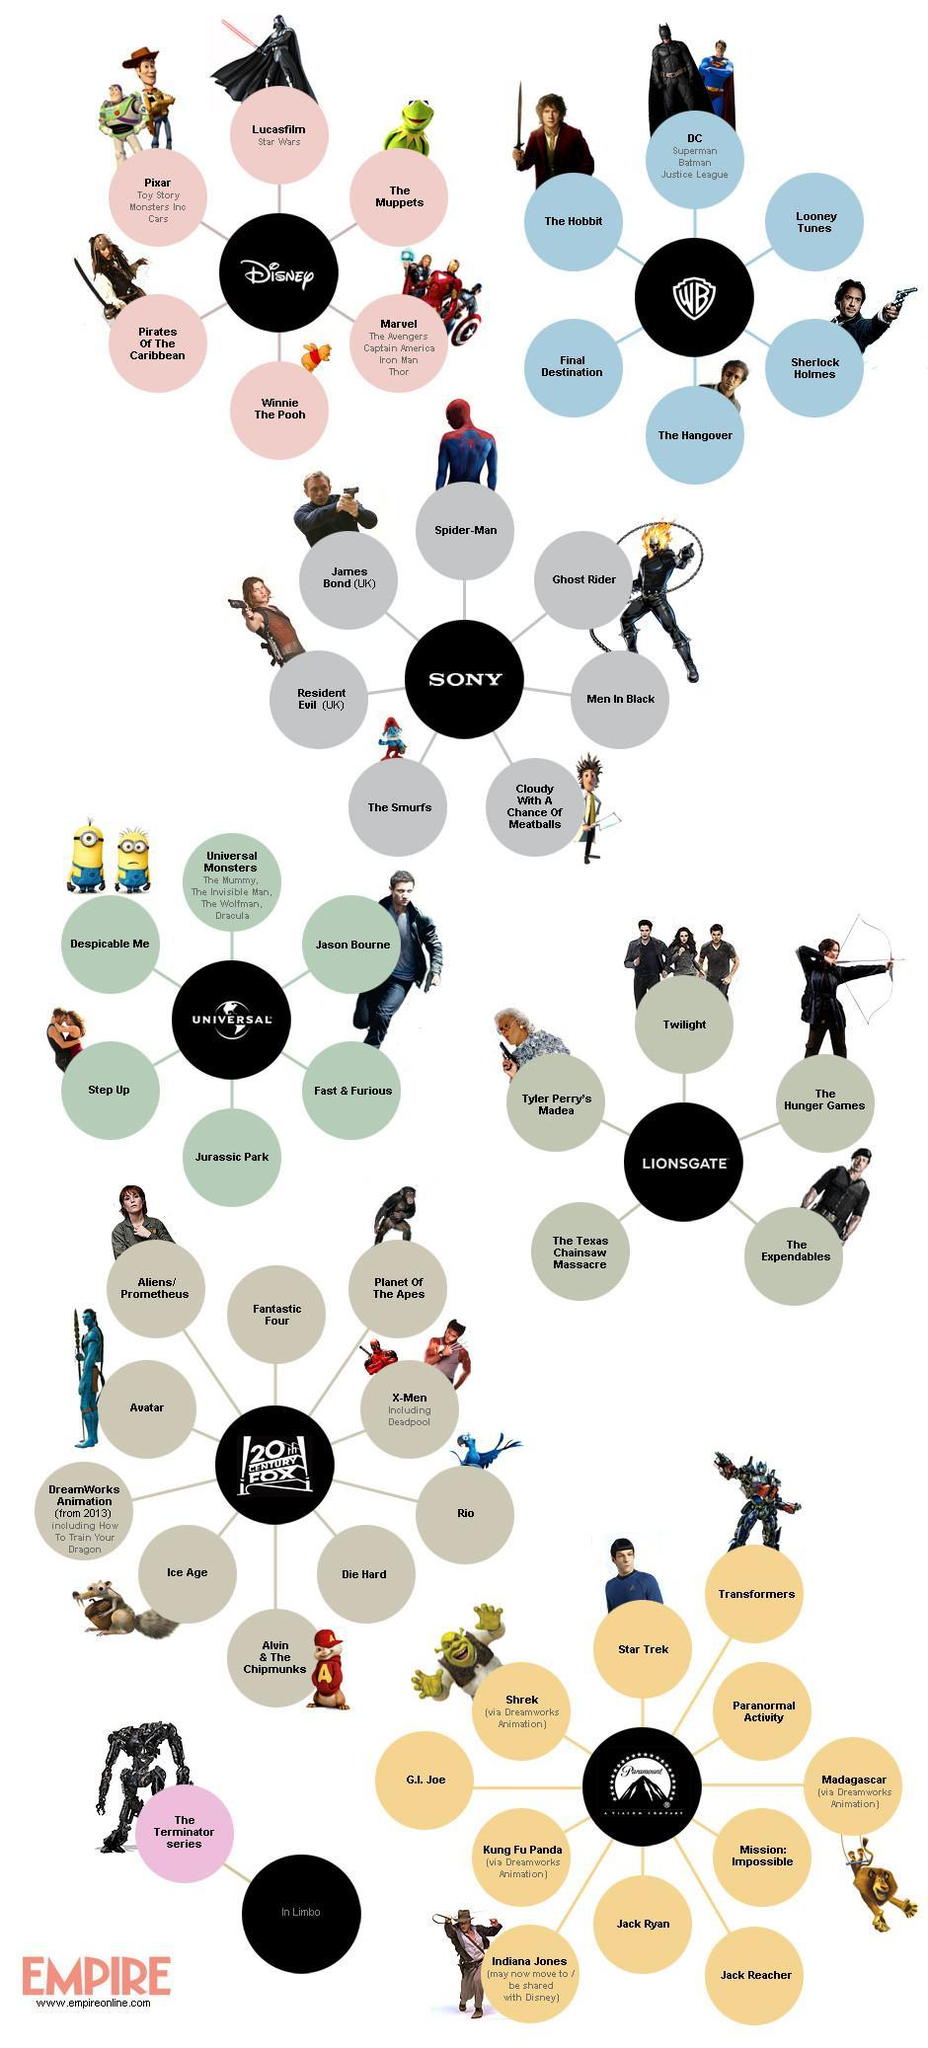Who produced movies like Star Trek, Paranormal activity, and Mission : Impossible ?
Answer the question with a short phrase. Paramount Which production company never collaborated with Dreamworks to make animation movies, 20th Century Fox, Paramount, or Universal? Universal Which production company created the Marvel heroes, Disney, DC, or Sony? Disney Who played the titular role of James Bond, Tobey Maguire, Nicholas Cage, or Daniel Craig? Daniel Craig How many animation movies were created by Paramount in association with Dreamworks? 4 Which super hero movie was produced by Sony, Captain America, Justice League, or Spiderman? Spiderman Which company production is represented by the letters WB, Warner Bros, Walter Bros, or Wright Bros? Warner Bros 